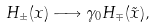Convert formula to latex. <formula><loc_0><loc_0><loc_500><loc_500>H _ { \pm } ( x ) \longrightarrow \gamma _ { 0 } H _ { \mp } ( \tilde { x } ) ,</formula> 